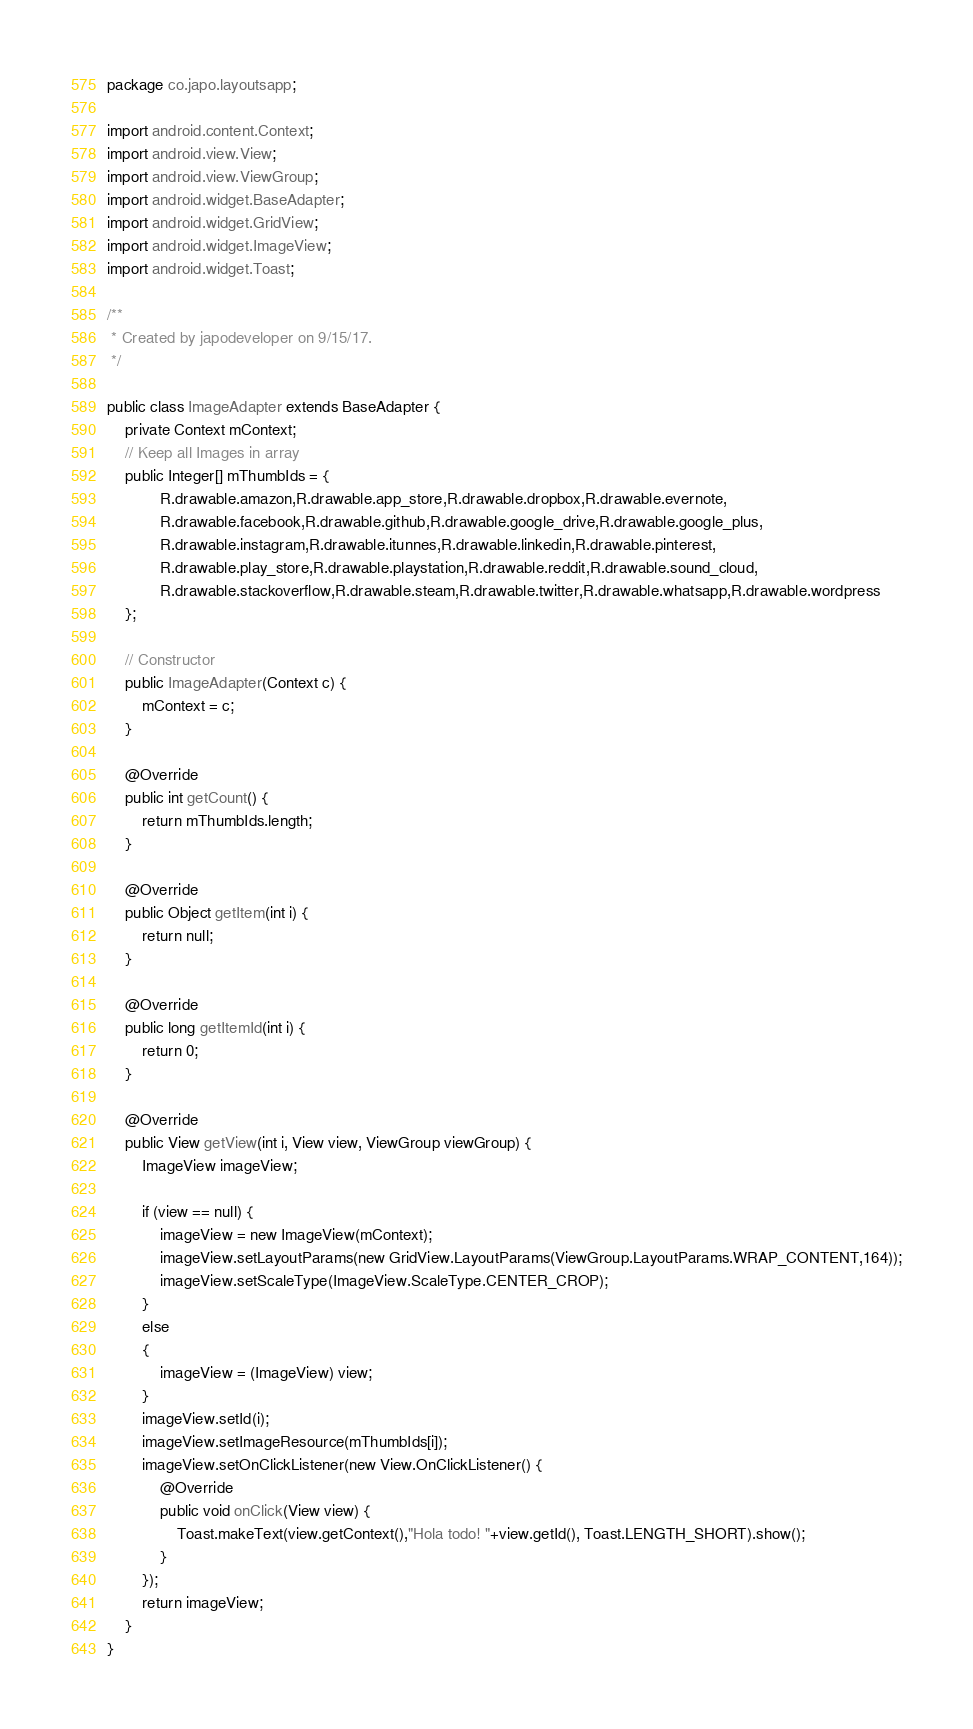Convert code to text. <code><loc_0><loc_0><loc_500><loc_500><_Java_>package co.japo.layoutsapp;

import android.content.Context;
import android.view.View;
import android.view.ViewGroup;
import android.widget.BaseAdapter;
import android.widget.GridView;
import android.widget.ImageView;
import android.widget.Toast;

/**
 * Created by japodeveloper on 9/15/17.
 */

public class ImageAdapter extends BaseAdapter {
    private Context mContext;
    // Keep all Images in array
    public Integer[] mThumbIds = {
            R.drawable.amazon,R.drawable.app_store,R.drawable.dropbox,R.drawable.evernote,
            R.drawable.facebook,R.drawable.github,R.drawable.google_drive,R.drawable.google_plus,
            R.drawable.instagram,R.drawable.itunnes,R.drawable.linkedin,R.drawable.pinterest,
            R.drawable.play_store,R.drawable.playstation,R.drawable.reddit,R.drawable.sound_cloud,
            R.drawable.stackoverflow,R.drawable.steam,R.drawable.twitter,R.drawable.whatsapp,R.drawable.wordpress
    };

    // Constructor
    public ImageAdapter(Context c) {
        mContext = c;
    }

    @Override
    public int getCount() {
        return mThumbIds.length;
    }

    @Override
    public Object getItem(int i) {
        return null;
    }

    @Override
    public long getItemId(int i) {
        return 0;
    }

    @Override
    public View getView(int i, View view, ViewGroup viewGroup) {
        ImageView imageView;

        if (view == null) {
            imageView = new ImageView(mContext);
            imageView.setLayoutParams(new GridView.LayoutParams(ViewGroup.LayoutParams.WRAP_CONTENT,164));
            imageView.setScaleType(ImageView.ScaleType.CENTER_CROP);
        }
        else
        {
            imageView = (ImageView) view;
        }
        imageView.setId(i);
        imageView.setImageResource(mThumbIds[i]);
        imageView.setOnClickListener(new View.OnClickListener() {
            @Override
            public void onClick(View view) {
                Toast.makeText(view.getContext(),"Hola todo! "+view.getId(), Toast.LENGTH_SHORT).show();
            }
        });
        return imageView;
    }
}
</code> 